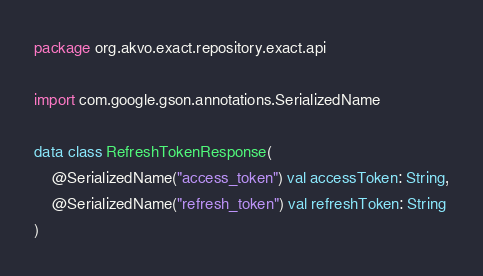<code> <loc_0><loc_0><loc_500><loc_500><_Kotlin_>package org.akvo.exact.repository.exact.api

import com.google.gson.annotations.SerializedName

data class RefreshTokenResponse(
    @SerializedName("access_token") val accessToken: String,
    @SerializedName("refresh_token") val refreshToken: String
)
</code> 